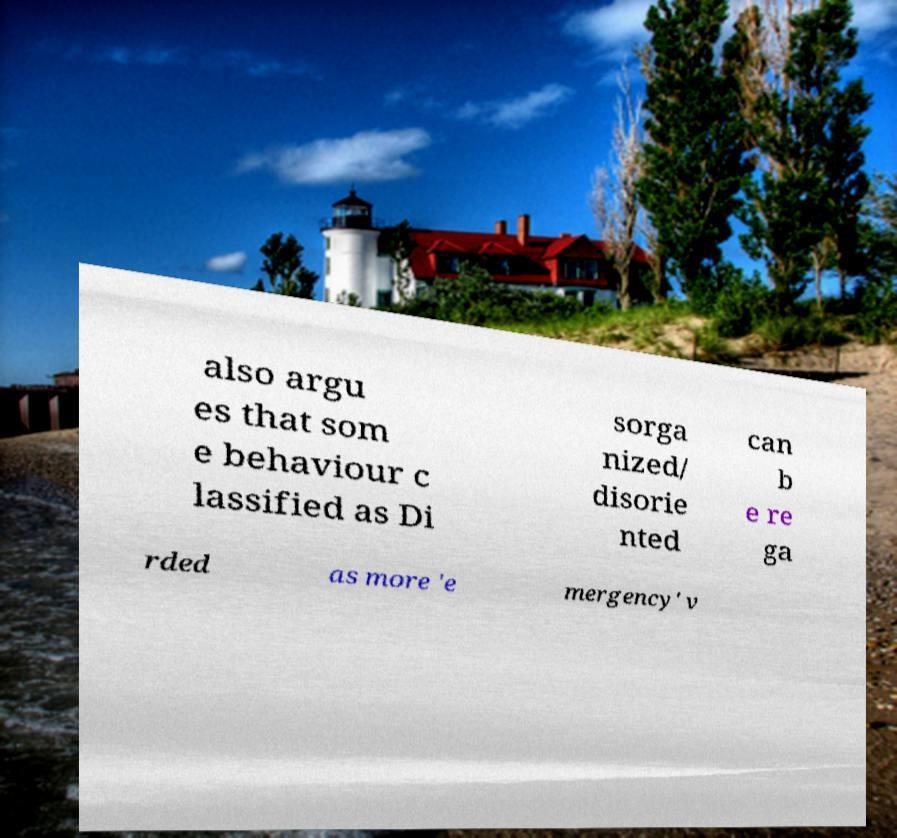Can you accurately transcribe the text from the provided image for me? also argu es that som e behaviour c lassified as Di sorga nized/ disorie nted can b e re ga rded as more 'e mergency' v 